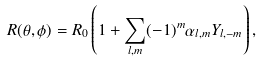Convert formula to latex. <formula><loc_0><loc_0><loc_500><loc_500>R ( \theta , \phi ) = R _ { 0 } \left ( 1 + \sum _ { l , m } ( - 1 ) ^ { m } \alpha _ { l , m } Y _ { l , - m } \right ) ,</formula> 